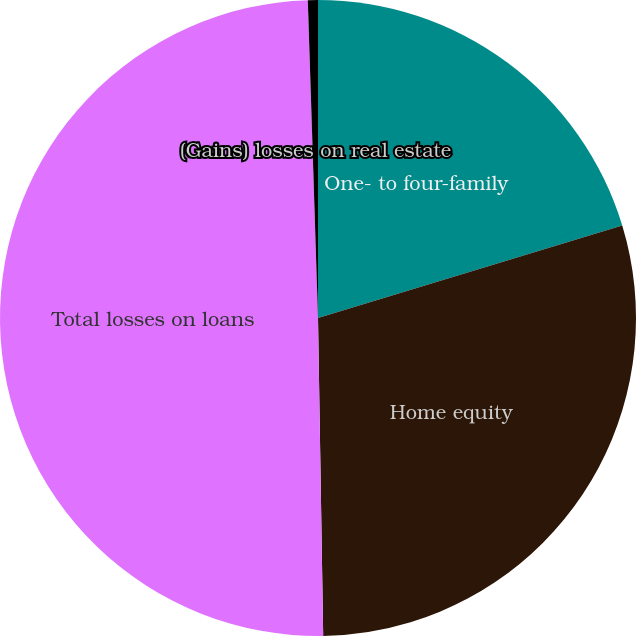<chart> <loc_0><loc_0><loc_500><loc_500><pie_chart><fcel>One- to four-family<fcel>Home equity<fcel>Total losses on loans<fcel>(Gains) losses on real estate<nl><fcel>20.3%<fcel>29.44%<fcel>49.75%<fcel>0.51%<nl></chart> 